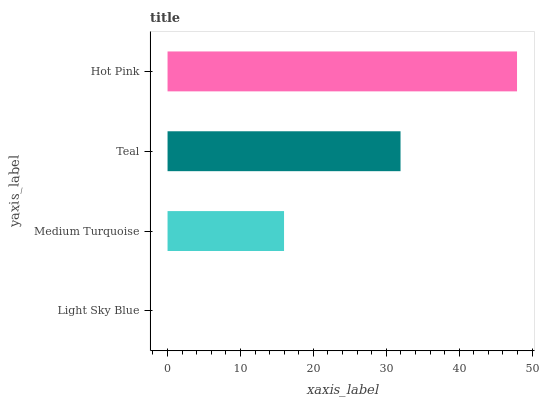Is Light Sky Blue the minimum?
Answer yes or no. Yes. Is Hot Pink the maximum?
Answer yes or no. Yes. Is Medium Turquoise the minimum?
Answer yes or no. No. Is Medium Turquoise the maximum?
Answer yes or no. No. Is Medium Turquoise greater than Light Sky Blue?
Answer yes or no. Yes. Is Light Sky Blue less than Medium Turquoise?
Answer yes or no. Yes. Is Light Sky Blue greater than Medium Turquoise?
Answer yes or no. No. Is Medium Turquoise less than Light Sky Blue?
Answer yes or no. No. Is Teal the high median?
Answer yes or no. Yes. Is Medium Turquoise the low median?
Answer yes or no. Yes. Is Light Sky Blue the high median?
Answer yes or no. No. Is Teal the low median?
Answer yes or no. No. 